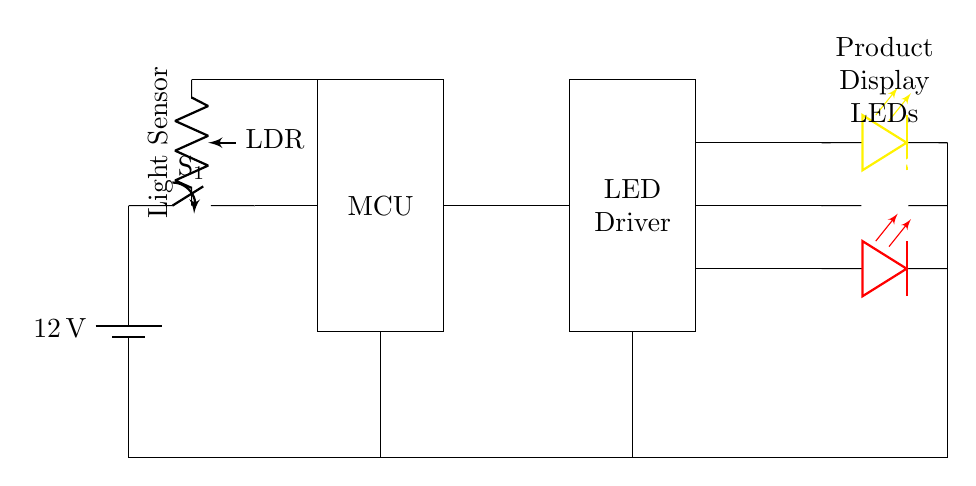What is the voltage used in this circuit? The voltage is indicated as 12 V, which is the supply voltage from the battery.
Answer: 12 V What type of components are the items labeled as LDR? The LDR stands for Light Dependent Resistor, which is a type of passive component that changes its resistance based on light intensity.
Answer: Light Dependent Resistor How many LEDs are in this circuit? There are three LEDs connected in this circuit, each with a different color: yellow, white, and red.
Answer: Three What is the role of the microcontroller in this circuit? The microcontroller, labeled as MCU, is likely responsible for controlling the LED Driver based on inputs from the LDR and other logic.
Answer: Control What type of switch is used in this circuit? The switch marked as S1 is a main switch that allows or interrupts the power flow in the circuit.
Answer: Main switch Which components are connected directly to ground? The ground connections are established from the battery, LDR, LED Driver, and LEDs, ensuring they all share a common return path.
Answer: Battery, LDR, LED Driver, LEDs How do the product display LEDs get their power? The product display LEDs receive their power from the LED Driver, which is connected to the main switch and the power supply.
Answer: LED Driver 